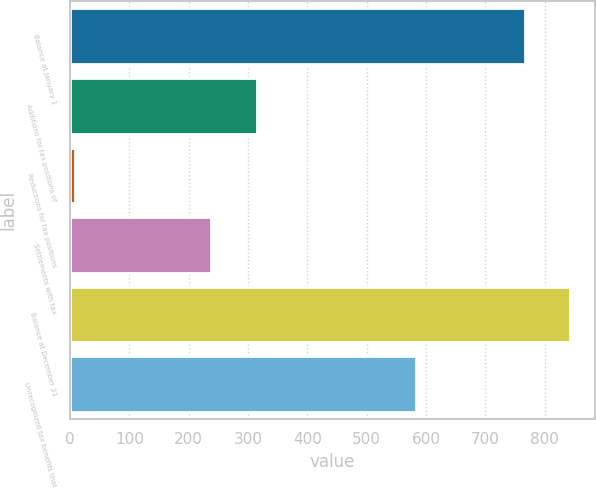Convert chart. <chart><loc_0><loc_0><loc_500><loc_500><bar_chart><fcel>Balance at January 1<fcel>Additions for tax positions of<fcel>Reductions for tax positions<fcel>Settlements with tax<fcel>Balance at December 31<fcel>Unrecognized tax benefits that<nl><fcel>766<fcel>314.6<fcel>9<fcel>238.2<fcel>842.4<fcel>583<nl></chart> 